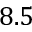<formula> <loc_0><loc_0><loc_500><loc_500>8 . 5</formula> 